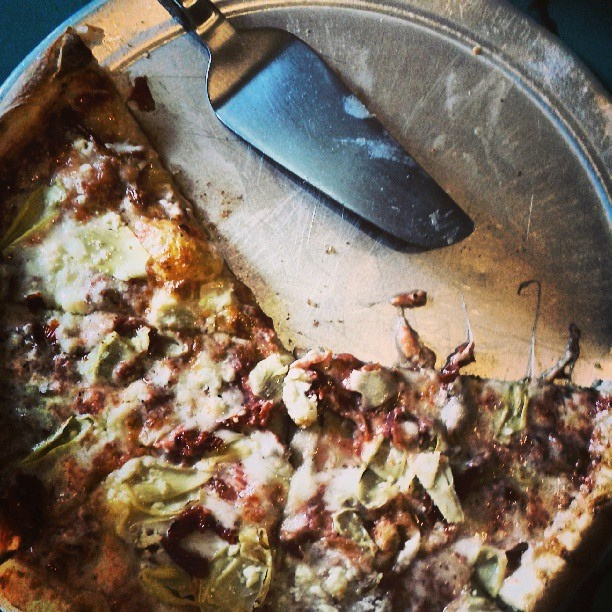Describe the objects in this image and their specific colors. I can see pizza in darkblue, black, maroon, and lightgray tones and knife in darkblue, black, gray, and blue tones in this image. 